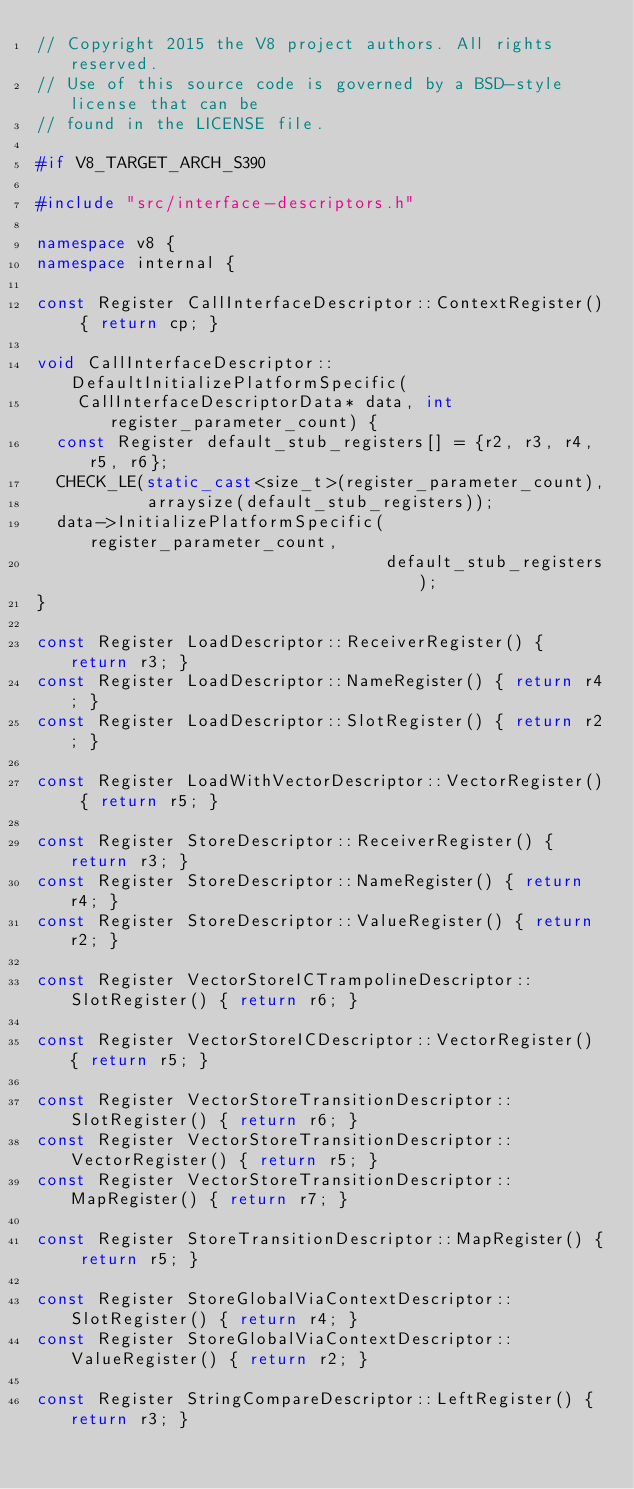Convert code to text. <code><loc_0><loc_0><loc_500><loc_500><_C++_>// Copyright 2015 the V8 project authors. All rights reserved.
// Use of this source code is governed by a BSD-style license that can be
// found in the LICENSE file.

#if V8_TARGET_ARCH_S390

#include "src/interface-descriptors.h"

namespace v8 {
namespace internal {

const Register CallInterfaceDescriptor::ContextRegister() { return cp; }

void CallInterfaceDescriptor::DefaultInitializePlatformSpecific(
    CallInterfaceDescriptorData* data, int register_parameter_count) {
  const Register default_stub_registers[] = {r2, r3, r4, r5, r6};
  CHECK_LE(static_cast<size_t>(register_parameter_count),
           arraysize(default_stub_registers));
  data->InitializePlatformSpecific(register_parameter_count,
                                   default_stub_registers);
}

const Register LoadDescriptor::ReceiverRegister() { return r3; }
const Register LoadDescriptor::NameRegister() { return r4; }
const Register LoadDescriptor::SlotRegister() { return r2; }

const Register LoadWithVectorDescriptor::VectorRegister() { return r5; }

const Register StoreDescriptor::ReceiverRegister() { return r3; }
const Register StoreDescriptor::NameRegister() { return r4; }
const Register StoreDescriptor::ValueRegister() { return r2; }

const Register VectorStoreICTrampolineDescriptor::SlotRegister() { return r6; }

const Register VectorStoreICDescriptor::VectorRegister() { return r5; }

const Register VectorStoreTransitionDescriptor::SlotRegister() { return r6; }
const Register VectorStoreTransitionDescriptor::VectorRegister() { return r5; }
const Register VectorStoreTransitionDescriptor::MapRegister() { return r7; }

const Register StoreTransitionDescriptor::MapRegister() { return r5; }

const Register StoreGlobalViaContextDescriptor::SlotRegister() { return r4; }
const Register StoreGlobalViaContextDescriptor::ValueRegister() { return r2; }

const Register StringCompareDescriptor::LeftRegister() { return r3; }</code> 